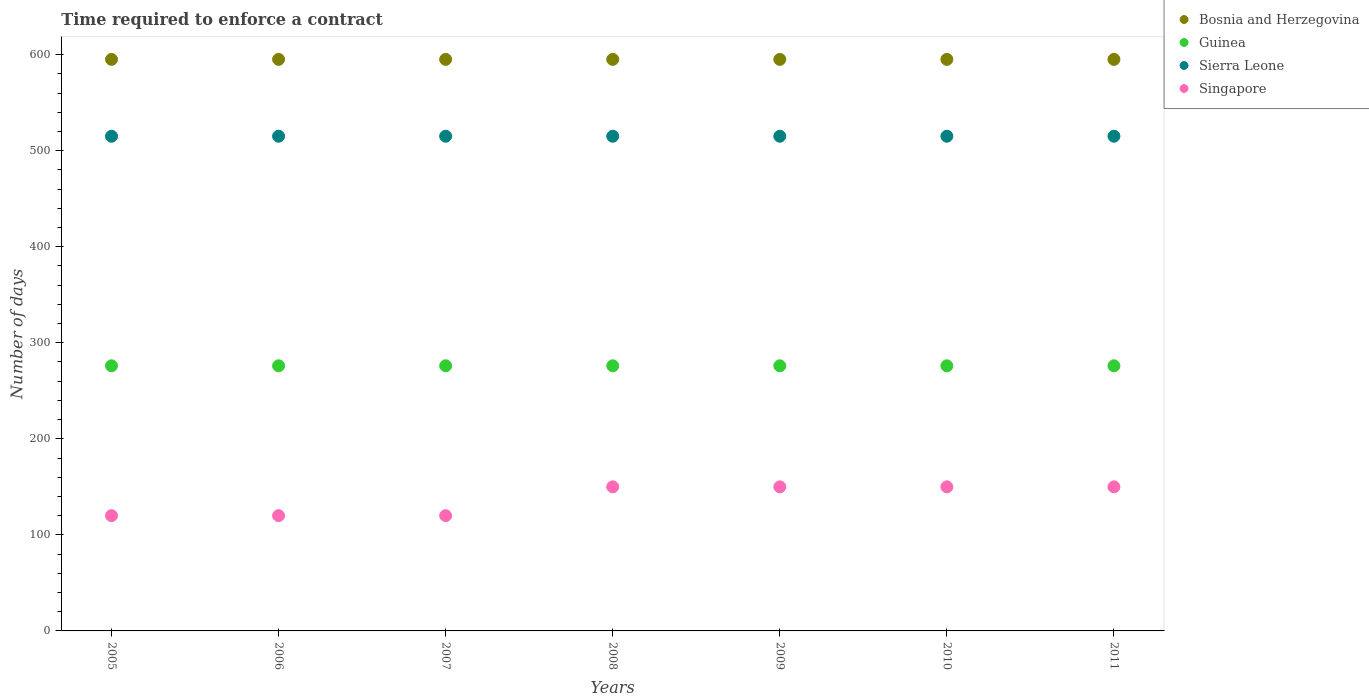How many different coloured dotlines are there?
Your response must be concise. 4. What is the number of days required to enforce a contract in Guinea in 2008?
Offer a terse response. 276. Across all years, what is the maximum number of days required to enforce a contract in Guinea?
Your response must be concise. 276. Across all years, what is the minimum number of days required to enforce a contract in Guinea?
Make the answer very short. 276. In which year was the number of days required to enforce a contract in Guinea maximum?
Give a very brief answer. 2005. In which year was the number of days required to enforce a contract in Bosnia and Herzegovina minimum?
Provide a short and direct response. 2005. What is the total number of days required to enforce a contract in Guinea in the graph?
Your response must be concise. 1932. What is the difference between the number of days required to enforce a contract in Guinea in 2011 and the number of days required to enforce a contract in Singapore in 2010?
Your answer should be compact. 126. What is the average number of days required to enforce a contract in Guinea per year?
Give a very brief answer. 276. In the year 2006, what is the difference between the number of days required to enforce a contract in Sierra Leone and number of days required to enforce a contract in Bosnia and Herzegovina?
Provide a short and direct response. -80. In how many years, is the number of days required to enforce a contract in Singapore greater than 580 days?
Offer a very short reply. 0. Is the number of days required to enforce a contract in Bosnia and Herzegovina in 2009 less than that in 2010?
Your answer should be compact. No. Is the difference between the number of days required to enforce a contract in Sierra Leone in 2007 and 2010 greater than the difference between the number of days required to enforce a contract in Bosnia and Herzegovina in 2007 and 2010?
Provide a succinct answer. No. What is the difference between the highest and the lowest number of days required to enforce a contract in Singapore?
Make the answer very short. 30. Is the number of days required to enforce a contract in Bosnia and Herzegovina strictly greater than the number of days required to enforce a contract in Sierra Leone over the years?
Provide a succinct answer. Yes. Is the number of days required to enforce a contract in Bosnia and Herzegovina strictly less than the number of days required to enforce a contract in Guinea over the years?
Your answer should be compact. No. How many years are there in the graph?
Offer a very short reply. 7. What is the difference between two consecutive major ticks on the Y-axis?
Provide a short and direct response. 100. Are the values on the major ticks of Y-axis written in scientific E-notation?
Give a very brief answer. No. Does the graph contain any zero values?
Your answer should be compact. No. How are the legend labels stacked?
Ensure brevity in your answer.  Vertical. What is the title of the graph?
Make the answer very short. Time required to enforce a contract. What is the label or title of the X-axis?
Make the answer very short. Years. What is the label or title of the Y-axis?
Offer a very short reply. Number of days. What is the Number of days in Bosnia and Herzegovina in 2005?
Give a very brief answer. 595. What is the Number of days in Guinea in 2005?
Your response must be concise. 276. What is the Number of days of Sierra Leone in 2005?
Offer a terse response. 515. What is the Number of days of Singapore in 2005?
Provide a short and direct response. 120. What is the Number of days of Bosnia and Herzegovina in 2006?
Ensure brevity in your answer.  595. What is the Number of days of Guinea in 2006?
Provide a succinct answer. 276. What is the Number of days of Sierra Leone in 2006?
Your answer should be compact. 515. What is the Number of days in Singapore in 2006?
Your response must be concise. 120. What is the Number of days of Bosnia and Herzegovina in 2007?
Offer a very short reply. 595. What is the Number of days of Guinea in 2007?
Keep it short and to the point. 276. What is the Number of days in Sierra Leone in 2007?
Keep it short and to the point. 515. What is the Number of days in Singapore in 2007?
Your response must be concise. 120. What is the Number of days of Bosnia and Herzegovina in 2008?
Ensure brevity in your answer.  595. What is the Number of days in Guinea in 2008?
Your answer should be compact. 276. What is the Number of days of Sierra Leone in 2008?
Offer a very short reply. 515. What is the Number of days in Singapore in 2008?
Your response must be concise. 150. What is the Number of days in Bosnia and Herzegovina in 2009?
Your response must be concise. 595. What is the Number of days in Guinea in 2009?
Provide a succinct answer. 276. What is the Number of days of Sierra Leone in 2009?
Offer a very short reply. 515. What is the Number of days of Singapore in 2009?
Keep it short and to the point. 150. What is the Number of days in Bosnia and Herzegovina in 2010?
Ensure brevity in your answer.  595. What is the Number of days of Guinea in 2010?
Make the answer very short. 276. What is the Number of days in Sierra Leone in 2010?
Your response must be concise. 515. What is the Number of days in Singapore in 2010?
Ensure brevity in your answer.  150. What is the Number of days of Bosnia and Herzegovina in 2011?
Offer a very short reply. 595. What is the Number of days in Guinea in 2011?
Provide a succinct answer. 276. What is the Number of days of Sierra Leone in 2011?
Keep it short and to the point. 515. What is the Number of days in Singapore in 2011?
Offer a terse response. 150. Across all years, what is the maximum Number of days in Bosnia and Herzegovina?
Keep it short and to the point. 595. Across all years, what is the maximum Number of days in Guinea?
Your response must be concise. 276. Across all years, what is the maximum Number of days of Sierra Leone?
Your answer should be very brief. 515. Across all years, what is the maximum Number of days of Singapore?
Keep it short and to the point. 150. Across all years, what is the minimum Number of days of Bosnia and Herzegovina?
Provide a short and direct response. 595. Across all years, what is the minimum Number of days in Guinea?
Your answer should be compact. 276. Across all years, what is the minimum Number of days of Sierra Leone?
Your response must be concise. 515. Across all years, what is the minimum Number of days in Singapore?
Offer a terse response. 120. What is the total Number of days of Bosnia and Herzegovina in the graph?
Provide a short and direct response. 4165. What is the total Number of days of Guinea in the graph?
Keep it short and to the point. 1932. What is the total Number of days of Sierra Leone in the graph?
Provide a short and direct response. 3605. What is the total Number of days of Singapore in the graph?
Make the answer very short. 960. What is the difference between the Number of days in Bosnia and Herzegovina in 2005 and that in 2006?
Provide a short and direct response. 0. What is the difference between the Number of days of Sierra Leone in 2005 and that in 2006?
Keep it short and to the point. 0. What is the difference between the Number of days in Singapore in 2005 and that in 2006?
Your response must be concise. 0. What is the difference between the Number of days in Guinea in 2005 and that in 2007?
Make the answer very short. 0. What is the difference between the Number of days in Sierra Leone in 2005 and that in 2007?
Make the answer very short. 0. What is the difference between the Number of days in Singapore in 2005 and that in 2007?
Your answer should be compact. 0. What is the difference between the Number of days of Singapore in 2005 and that in 2008?
Give a very brief answer. -30. What is the difference between the Number of days of Bosnia and Herzegovina in 2005 and that in 2009?
Keep it short and to the point. 0. What is the difference between the Number of days in Sierra Leone in 2005 and that in 2009?
Keep it short and to the point. 0. What is the difference between the Number of days in Singapore in 2005 and that in 2009?
Make the answer very short. -30. What is the difference between the Number of days in Sierra Leone in 2005 and that in 2010?
Your answer should be compact. 0. What is the difference between the Number of days in Singapore in 2005 and that in 2011?
Keep it short and to the point. -30. What is the difference between the Number of days of Bosnia and Herzegovina in 2006 and that in 2007?
Keep it short and to the point. 0. What is the difference between the Number of days of Sierra Leone in 2006 and that in 2007?
Ensure brevity in your answer.  0. What is the difference between the Number of days of Singapore in 2006 and that in 2007?
Offer a terse response. 0. What is the difference between the Number of days in Bosnia and Herzegovina in 2006 and that in 2008?
Ensure brevity in your answer.  0. What is the difference between the Number of days in Singapore in 2006 and that in 2008?
Your answer should be compact. -30. What is the difference between the Number of days in Guinea in 2006 and that in 2010?
Ensure brevity in your answer.  0. What is the difference between the Number of days in Singapore in 2006 and that in 2010?
Make the answer very short. -30. What is the difference between the Number of days in Bosnia and Herzegovina in 2006 and that in 2011?
Give a very brief answer. 0. What is the difference between the Number of days in Guinea in 2006 and that in 2011?
Offer a very short reply. 0. What is the difference between the Number of days in Sierra Leone in 2006 and that in 2011?
Ensure brevity in your answer.  0. What is the difference between the Number of days of Singapore in 2006 and that in 2011?
Your answer should be compact. -30. What is the difference between the Number of days in Guinea in 2007 and that in 2009?
Offer a very short reply. 0. What is the difference between the Number of days in Guinea in 2007 and that in 2010?
Ensure brevity in your answer.  0. What is the difference between the Number of days in Sierra Leone in 2007 and that in 2010?
Give a very brief answer. 0. What is the difference between the Number of days of Singapore in 2007 and that in 2010?
Give a very brief answer. -30. What is the difference between the Number of days of Guinea in 2007 and that in 2011?
Provide a short and direct response. 0. What is the difference between the Number of days in Singapore in 2007 and that in 2011?
Your answer should be very brief. -30. What is the difference between the Number of days of Guinea in 2008 and that in 2009?
Your response must be concise. 0. What is the difference between the Number of days of Singapore in 2008 and that in 2009?
Provide a short and direct response. 0. What is the difference between the Number of days in Bosnia and Herzegovina in 2008 and that in 2010?
Keep it short and to the point. 0. What is the difference between the Number of days of Guinea in 2008 and that in 2010?
Keep it short and to the point. 0. What is the difference between the Number of days in Sierra Leone in 2008 and that in 2010?
Your answer should be very brief. 0. What is the difference between the Number of days of Singapore in 2008 and that in 2010?
Keep it short and to the point. 0. What is the difference between the Number of days in Guinea in 2008 and that in 2011?
Your answer should be compact. 0. What is the difference between the Number of days in Singapore in 2008 and that in 2011?
Your answer should be very brief. 0. What is the difference between the Number of days in Guinea in 2009 and that in 2010?
Your response must be concise. 0. What is the difference between the Number of days of Sierra Leone in 2009 and that in 2010?
Keep it short and to the point. 0. What is the difference between the Number of days of Sierra Leone in 2009 and that in 2011?
Your answer should be compact. 0. What is the difference between the Number of days of Bosnia and Herzegovina in 2010 and that in 2011?
Your response must be concise. 0. What is the difference between the Number of days in Guinea in 2010 and that in 2011?
Your answer should be compact. 0. What is the difference between the Number of days in Singapore in 2010 and that in 2011?
Your answer should be very brief. 0. What is the difference between the Number of days in Bosnia and Herzegovina in 2005 and the Number of days in Guinea in 2006?
Your response must be concise. 319. What is the difference between the Number of days in Bosnia and Herzegovina in 2005 and the Number of days in Singapore in 2006?
Keep it short and to the point. 475. What is the difference between the Number of days of Guinea in 2005 and the Number of days of Sierra Leone in 2006?
Your answer should be compact. -239. What is the difference between the Number of days in Guinea in 2005 and the Number of days in Singapore in 2006?
Give a very brief answer. 156. What is the difference between the Number of days of Sierra Leone in 2005 and the Number of days of Singapore in 2006?
Your answer should be compact. 395. What is the difference between the Number of days of Bosnia and Herzegovina in 2005 and the Number of days of Guinea in 2007?
Offer a terse response. 319. What is the difference between the Number of days in Bosnia and Herzegovina in 2005 and the Number of days in Singapore in 2007?
Your answer should be compact. 475. What is the difference between the Number of days in Guinea in 2005 and the Number of days in Sierra Leone in 2007?
Your answer should be compact. -239. What is the difference between the Number of days of Guinea in 2005 and the Number of days of Singapore in 2007?
Your response must be concise. 156. What is the difference between the Number of days in Sierra Leone in 2005 and the Number of days in Singapore in 2007?
Make the answer very short. 395. What is the difference between the Number of days in Bosnia and Herzegovina in 2005 and the Number of days in Guinea in 2008?
Ensure brevity in your answer.  319. What is the difference between the Number of days of Bosnia and Herzegovina in 2005 and the Number of days of Singapore in 2008?
Your response must be concise. 445. What is the difference between the Number of days in Guinea in 2005 and the Number of days in Sierra Leone in 2008?
Offer a terse response. -239. What is the difference between the Number of days in Guinea in 2005 and the Number of days in Singapore in 2008?
Provide a short and direct response. 126. What is the difference between the Number of days of Sierra Leone in 2005 and the Number of days of Singapore in 2008?
Provide a short and direct response. 365. What is the difference between the Number of days in Bosnia and Herzegovina in 2005 and the Number of days in Guinea in 2009?
Provide a succinct answer. 319. What is the difference between the Number of days in Bosnia and Herzegovina in 2005 and the Number of days in Singapore in 2009?
Offer a very short reply. 445. What is the difference between the Number of days of Guinea in 2005 and the Number of days of Sierra Leone in 2009?
Keep it short and to the point. -239. What is the difference between the Number of days of Guinea in 2005 and the Number of days of Singapore in 2009?
Ensure brevity in your answer.  126. What is the difference between the Number of days in Sierra Leone in 2005 and the Number of days in Singapore in 2009?
Give a very brief answer. 365. What is the difference between the Number of days in Bosnia and Herzegovina in 2005 and the Number of days in Guinea in 2010?
Make the answer very short. 319. What is the difference between the Number of days of Bosnia and Herzegovina in 2005 and the Number of days of Sierra Leone in 2010?
Provide a short and direct response. 80. What is the difference between the Number of days of Bosnia and Herzegovina in 2005 and the Number of days of Singapore in 2010?
Ensure brevity in your answer.  445. What is the difference between the Number of days in Guinea in 2005 and the Number of days in Sierra Leone in 2010?
Your answer should be compact. -239. What is the difference between the Number of days of Guinea in 2005 and the Number of days of Singapore in 2010?
Keep it short and to the point. 126. What is the difference between the Number of days in Sierra Leone in 2005 and the Number of days in Singapore in 2010?
Your response must be concise. 365. What is the difference between the Number of days in Bosnia and Herzegovina in 2005 and the Number of days in Guinea in 2011?
Your response must be concise. 319. What is the difference between the Number of days of Bosnia and Herzegovina in 2005 and the Number of days of Sierra Leone in 2011?
Keep it short and to the point. 80. What is the difference between the Number of days in Bosnia and Herzegovina in 2005 and the Number of days in Singapore in 2011?
Give a very brief answer. 445. What is the difference between the Number of days in Guinea in 2005 and the Number of days in Sierra Leone in 2011?
Offer a very short reply. -239. What is the difference between the Number of days in Guinea in 2005 and the Number of days in Singapore in 2011?
Offer a very short reply. 126. What is the difference between the Number of days of Sierra Leone in 2005 and the Number of days of Singapore in 2011?
Provide a succinct answer. 365. What is the difference between the Number of days in Bosnia and Herzegovina in 2006 and the Number of days in Guinea in 2007?
Your response must be concise. 319. What is the difference between the Number of days of Bosnia and Herzegovina in 2006 and the Number of days of Singapore in 2007?
Provide a short and direct response. 475. What is the difference between the Number of days in Guinea in 2006 and the Number of days in Sierra Leone in 2007?
Keep it short and to the point. -239. What is the difference between the Number of days in Guinea in 2006 and the Number of days in Singapore in 2007?
Offer a terse response. 156. What is the difference between the Number of days in Sierra Leone in 2006 and the Number of days in Singapore in 2007?
Your answer should be very brief. 395. What is the difference between the Number of days in Bosnia and Herzegovina in 2006 and the Number of days in Guinea in 2008?
Offer a very short reply. 319. What is the difference between the Number of days of Bosnia and Herzegovina in 2006 and the Number of days of Singapore in 2008?
Offer a very short reply. 445. What is the difference between the Number of days of Guinea in 2006 and the Number of days of Sierra Leone in 2008?
Provide a short and direct response. -239. What is the difference between the Number of days in Guinea in 2006 and the Number of days in Singapore in 2008?
Your answer should be compact. 126. What is the difference between the Number of days of Sierra Leone in 2006 and the Number of days of Singapore in 2008?
Give a very brief answer. 365. What is the difference between the Number of days of Bosnia and Herzegovina in 2006 and the Number of days of Guinea in 2009?
Give a very brief answer. 319. What is the difference between the Number of days of Bosnia and Herzegovina in 2006 and the Number of days of Sierra Leone in 2009?
Ensure brevity in your answer.  80. What is the difference between the Number of days of Bosnia and Herzegovina in 2006 and the Number of days of Singapore in 2009?
Your answer should be very brief. 445. What is the difference between the Number of days of Guinea in 2006 and the Number of days of Sierra Leone in 2009?
Make the answer very short. -239. What is the difference between the Number of days in Guinea in 2006 and the Number of days in Singapore in 2009?
Your answer should be compact. 126. What is the difference between the Number of days in Sierra Leone in 2006 and the Number of days in Singapore in 2009?
Your answer should be compact. 365. What is the difference between the Number of days of Bosnia and Herzegovina in 2006 and the Number of days of Guinea in 2010?
Make the answer very short. 319. What is the difference between the Number of days in Bosnia and Herzegovina in 2006 and the Number of days in Singapore in 2010?
Provide a succinct answer. 445. What is the difference between the Number of days of Guinea in 2006 and the Number of days of Sierra Leone in 2010?
Offer a very short reply. -239. What is the difference between the Number of days of Guinea in 2006 and the Number of days of Singapore in 2010?
Give a very brief answer. 126. What is the difference between the Number of days of Sierra Leone in 2006 and the Number of days of Singapore in 2010?
Your answer should be very brief. 365. What is the difference between the Number of days in Bosnia and Herzegovina in 2006 and the Number of days in Guinea in 2011?
Make the answer very short. 319. What is the difference between the Number of days of Bosnia and Herzegovina in 2006 and the Number of days of Sierra Leone in 2011?
Provide a succinct answer. 80. What is the difference between the Number of days in Bosnia and Herzegovina in 2006 and the Number of days in Singapore in 2011?
Ensure brevity in your answer.  445. What is the difference between the Number of days of Guinea in 2006 and the Number of days of Sierra Leone in 2011?
Ensure brevity in your answer.  -239. What is the difference between the Number of days in Guinea in 2006 and the Number of days in Singapore in 2011?
Ensure brevity in your answer.  126. What is the difference between the Number of days in Sierra Leone in 2006 and the Number of days in Singapore in 2011?
Provide a succinct answer. 365. What is the difference between the Number of days in Bosnia and Herzegovina in 2007 and the Number of days in Guinea in 2008?
Give a very brief answer. 319. What is the difference between the Number of days of Bosnia and Herzegovina in 2007 and the Number of days of Singapore in 2008?
Ensure brevity in your answer.  445. What is the difference between the Number of days of Guinea in 2007 and the Number of days of Sierra Leone in 2008?
Offer a terse response. -239. What is the difference between the Number of days of Guinea in 2007 and the Number of days of Singapore in 2008?
Ensure brevity in your answer.  126. What is the difference between the Number of days in Sierra Leone in 2007 and the Number of days in Singapore in 2008?
Ensure brevity in your answer.  365. What is the difference between the Number of days of Bosnia and Herzegovina in 2007 and the Number of days of Guinea in 2009?
Keep it short and to the point. 319. What is the difference between the Number of days in Bosnia and Herzegovina in 2007 and the Number of days in Singapore in 2009?
Ensure brevity in your answer.  445. What is the difference between the Number of days of Guinea in 2007 and the Number of days of Sierra Leone in 2009?
Give a very brief answer. -239. What is the difference between the Number of days of Guinea in 2007 and the Number of days of Singapore in 2009?
Provide a short and direct response. 126. What is the difference between the Number of days of Sierra Leone in 2007 and the Number of days of Singapore in 2009?
Give a very brief answer. 365. What is the difference between the Number of days in Bosnia and Herzegovina in 2007 and the Number of days in Guinea in 2010?
Your answer should be compact. 319. What is the difference between the Number of days of Bosnia and Herzegovina in 2007 and the Number of days of Singapore in 2010?
Ensure brevity in your answer.  445. What is the difference between the Number of days in Guinea in 2007 and the Number of days in Sierra Leone in 2010?
Provide a short and direct response. -239. What is the difference between the Number of days in Guinea in 2007 and the Number of days in Singapore in 2010?
Provide a succinct answer. 126. What is the difference between the Number of days in Sierra Leone in 2007 and the Number of days in Singapore in 2010?
Make the answer very short. 365. What is the difference between the Number of days of Bosnia and Herzegovina in 2007 and the Number of days of Guinea in 2011?
Offer a very short reply. 319. What is the difference between the Number of days in Bosnia and Herzegovina in 2007 and the Number of days in Sierra Leone in 2011?
Provide a short and direct response. 80. What is the difference between the Number of days of Bosnia and Herzegovina in 2007 and the Number of days of Singapore in 2011?
Your response must be concise. 445. What is the difference between the Number of days of Guinea in 2007 and the Number of days of Sierra Leone in 2011?
Provide a short and direct response. -239. What is the difference between the Number of days in Guinea in 2007 and the Number of days in Singapore in 2011?
Make the answer very short. 126. What is the difference between the Number of days in Sierra Leone in 2007 and the Number of days in Singapore in 2011?
Offer a terse response. 365. What is the difference between the Number of days in Bosnia and Herzegovina in 2008 and the Number of days in Guinea in 2009?
Provide a succinct answer. 319. What is the difference between the Number of days in Bosnia and Herzegovina in 2008 and the Number of days in Singapore in 2009?
Offer a very short reply. 445. What is the difference between the Number of days of Guinea in 2008 and the Number of days of Sierra Leone in 2009?
Offer a terse response. -239. What is the difference between the Number of days of Guinea in 2008 and the Number of days of Singapore in 2009?
Your response must be concise. 126. What is the difference between the Number of days of Sierra Leone in 2008 and the Number of days of Singapore in 2009?
Provide a short and direct response. 365. What is the difference between the Number of days in Bosnia and Herzegovina in 2008 and the Number of days in Guinea in 2010?
Your response must be concise. 319. What is the difference between the Number of days of Bosnia and Herzegovina in 2008 and the Number of days of Sierra Leone in 2010?
Provide a succinct answer. 80. What is the difference between the Number of days in Bosnia and Herzegovina in 2008 and the Number of days in Singapore in 2010?
Offer a very short reply. 445. What is the difference between the Number of days of Guinea in 2008 and the Number of days of Sierra Leone in 2010?
Offer a very short reply. -239. What is the difference between the Number of days of Guinea in 2008 and the Number of days of Singapore in 2010?
Offer a terse response. 126. What is the difference between the Number of days of Sierra Leone in 2008 and the Number of days of Singapore in 2010?
Your answer should be compact. 365. What is the difference between the Number of days in Bosnia and Herzegovina in 2008 and the Number of days in Guinea in 2011?
Make the answer very short. 319. What is the difference between the Number of days in Bosnia and Herzegovina in 2008 and the Number of days in Sierra Leone in 2011?
Provide a short and direct response. 80. What is the difference between the Number of days in Bosnia and Herzegovina in 2008 and the Number of days in Singapore in 2011?
Make the answer very short. 445. What is the difference between the Number of days in Guinea in 2008 and the Number of days in Sierra Leone in 2011?
Your answer should be very brief. -239. What is the difference between the Number of days in Guinea in 2008 and the Number of days in Singapore in 2011?
Offer a very short reply. 126. What is the difference between the Number of days in Sierra Leone in 2008 and the Number of days in Singapore in 2011?
Keep it short and to the point. 365. What is the difference between the Number of days of Bosnia and Herzegovina in 2009 and the Number of days of Guinea in 2010?
Make the answer very short. 319. What is the difference between the Number of days of Bosnia and Herzegovina in 2009 and the Number of days of Singapore in 2010?
Make the answer very short. 445. What is the difference between the Number of days of Guinea in 2009 and the Number of days of Sierra Leone in 2010?
Ensure brevity in your answer.  -239. What is the difference between the Number of days in Guinea in 2009 and the Number of days in Singapore in 2010?
Your response must be concise. 126. What is the difference between the Number of days in Sierra Leone in 2009 and the Number of days in Singapore in 2010?
Your answer should be compact. 365. What is the difference between the Number of days in Bosnia and Herzegovina in 2009 and the Number of days in Guinea in 2011?
Make the answer very short. 319. What is the difference between the Number of days of Bosnia and Herzegovina in 2009 and the Number of days of Singapore in 2011?
Provide a succinct answer. 445. What is the difference between the Number of days in Guinea in 2009 and the Number of days in Sierra Leone in 2011?
Offer a very short reply. -239. What is the difference between the Number of days of Guinea in 2009 and the Number of days of Singapore in 2011?
Offer a terse response. 126. What is the difference between the Number of days of Sierra Leone in 2009 and the Number of days of Singapore in 2011?
Offer a terse response. 365. What is the difference between the Number of days in Bosnia and Herzegovina in 2010 and the Number of days in Guinea in 2011?
Ensure brevity in your answer.  319. What is the difference between the Number of days of Bosnia and Herzegovina in 2010 and the Number of days of Singapore in 2011?
Your answer should be very brief. 445. What is the difference between the Number of days in Guinea in 2010 and the Number of days in Sierra Leone in 2011?
Offer a terse response. -239. What is the difference between the Number of days of Guinea in 2010 and the Number of days of Singapore in 2011?
Provide a short and direct response. 126. What is the difference between the Number of days of Sierra Leone in 2010 and the Number of days of Singapore in 2011?
Provide a short and direct response. 365. What is the average Number of days of Bosnia and Herzegovina per year?
Your response must be concise. 595. What is the average Number of days of Guinea per year?
Offer a very short reply. 276. What is the average Number of days in Sierra Leone per year?
Your response must be concise. 515. What is the average Number of days in Singapore per year?
Make the answer very short. 137.14. In the year 2005, what is the difference between the Number of days in Bosnia and Herzegovina and Number of days in Guinea?
Your answer should be compact. 319. In the year 2005, what is the difference between the Number of days of Bosnia and Herzegovina and Number of days of Sierra Leone?
Provide a succinct answer. 80. In the year 2005, what is the difference between the Number of days in Bosnia and Herzegovina and Number of days in Singapore?
Offer a terse response. 475. In the year 2005, what is the difference between the Number of days of Guinea and Number of days of Sierra Leone?
Keep it short and to the point. -239. In the year 2005, what is the difference between the Number of days of Guinea and Number of days of Singapore?
Offer a terse response. 156. In the year 2005, what is the difference between the Number of days in Sierra Leone and Number of days in Singapore?
Your response must be concise. 395. In the year 2006, what is the difference between the Number of days of Bosnia and Herzegovina and Number of days of Guinea?
Make the answer very short. 319. In the year 2006, what is the difference between the Number of days of Bosnia and Herzegovina and Number of days of Sierra Leone?
Ensure brevity in your answer.  80. In the year 2006, what is the difference between the Number of days of Bosnia and Herzegovina and Number of days of Singapore?
Your answer should be compact. 475. In the year 2006, what is the difference between the Number of days of Guinea and Number of days of Sierra Leone?
Your answer should be very brief. -239. In the year 2006, what is the difference between the Number of days of Guinea and Number of days of Singapore?
Offer a terse response. 156. In the year 2006, what is the difference between the Number of days of Sierra Leone and Number of days of Singapore?
Your response must be concise. 395. In the year 2007, what is the difference between the Number of days of Bosnia and Herzegovina and Number of days of Guinea?
Your answer should be compact. 319. In the year 2007, what is the difference between the Number of days of Bosnia and Herzegovina and Number of days of Singapore?
Keep it short and to the point. 475. In the year 2007, what is the difference between the Number of days of Guinea and Number of days of Sierra Leone?
Give a very brief answer. -239. In the year 2007, what is the difference between the Number of days in Guinea and Number of days in Singapore?
Offer a terse response. 156. In the year 2007, what is the difference between the Number of days in Sierra Leone and Number of days in Singapore?
Offer a terse response. 395. In the year 2008, what is the difference between the Number of days of Bosnia and Herzegovina and Number of days of Guinea?
Your response must be concise. 319. In the year 2008, what is the difference between the Number of days of Bosnia and Herzegovina and Number of days of Singapore?
Offer a terse response. 445. In the year 2008, what is the difference between the Number of days in Guinea and Number of days in Sierra Leone?
Your answer should be very brief. -239. In the year 2008, what is the difference between the Number of days in Guinea and Number of days in Singapore?
Your response must be concise. 126. In the year 2008, what is the difference between the Number of days of Sierra Leone and Number of days of Singapore?
Your response must be concise. 365. In the year 2009, what is the difference between the Number of days of Bosnia and Herzegovina and Number of days of Guinea?
Provide a succinct answer. 319. In the year 2009, what is the difference between the Number of days of Bosnia and Herzegovina and Number of days of Singapore?
Offer a terse response. 445. In the year 2009, what is the difference between the Number of days of Guinea and Number of days of Sierra Leone?
Your answer should be very brief. -239. In the year 2009, what is the difference between the Number of days in Guinea and Number of days in Singapore?
Offer a terse response. 126. In the year 2009, what is the difference between the Number of days of Sierra Leone and Number of days of Singapore?
Give a very brief answer. 365. In the year 2010, what is the difference between the Number of days in Bosnia and Herzegovina and Number of days in Guinea?
Your response must be concise. 319. In the year 2010, what is the difference between the Number of days of Bosnia and Herzegovina and Number of days of Singapore?
Your answer should be very brief. 445. In the year 2010, what is the difference between the Number of days of Guinea and Number of days of Sierra Leone?
Keep it short and to the point. -239. In the year 2010, what is the difference between the Number of days of Guinea and Number of days of Singapore?
Give a very brief answer. 126. In the year 2010, what is the difference between the Number of days of Sierra Leone and Number of days of Singapore?
Offer a terse response. 365. In the year 2011, what is the difference between the Number of days in Bosnia and Herzegovina and Number of days in Guinea?
Offer a terse response. 319. In the year 2011, what is the difference between the Number of days in Bosnia and Herzegovina and Number of days in Sierra Leone?
Your response must be concise. 80. In the year 2011, what is the difference between the Number of days in Bosnia and Herzegovina and Number of days in Singapore?
Offer a very short reply. 445. In the year 2011, what is the difference between the Number of days of Guinea and Number of days of Sierra Leone?
Provide a succinct answer. -239. In the year 2011, what is the difference between the Number of days in Guinea and Number of days in Singapore?
Your answer should be compact. 126. In the year 2011, what is the difference between the Number of days of Sierra Leone and Number of days of Singapore?
Your response must be concise. 365. What is the ratio of the Number of days in Guinea in 2005 to that in 2006?
Your answer should be compact. 1. What is the ratio of the Number of days in Sierra Leone in 2005 to that in 2007?
Provide a succinct answer. 1. What is the ratio of the Number of days in Singapore in 2005 to that in 2007?
Your response must be concise. 1. What is the ratio of the Number of days of Sierra Leone in 2005 to that in 2008?
Give a very brief answer. 1. What is the ratio of the Number of days in Guinea in 2005 to that in 2009?
Provide a short and direct response. 1. What is the ratio of the Number of days in Singapore in 2005 to that in 2009?
Your answer should be very brief. 0.8. What is the ratio of the Number of days in Bosnia and Herzegovina in 2005 to that in 2011?
Provide a succinct answer. 1. What is the ratio of the Number of days of Singapore in 2005 to that in 2011?
Your response must be concise. 0.8. What is the ratio of the Number of days in Guinea in 2006 to that in 2007?
Your response must be concise. 1. What is the ratio of the Number of days of Sierra Leone in 2006 to that in 2007?
Make the answer very short. 1. What is the ratio of the Number of days of Singapore in 2006 to that in 2007?
Make the answer very short. 1. What is the ratio of the Number of days of Bosnia and Herzegovina in 2006 to that in 2008?
Your response must be concise. 1. What is the ratio of the Number of days of Guinea in 2006 to that in 2008?
Give a very brief answer. 1. What is the ratio of the Number of days in Sierra Leone in 2006 to that in 2008?
Offer a very short reply. 1. What is the ratio of the Number of days in Singapore in 2006 to that in 2008?
Offer a very short reply. 0.8. What is the ratio of the Number of days in Bosnia and Herzegovina in 2006 to that in 2009?
Give a very brief answer. 1. What is the ratio of the Number of days in Singapore in 2006 to that in 2009?
Keep it short and to the point. 0.8. What is the ratio of the Number of days of Bosnia and Herzegovina in 2006 to that in 2011?
Keep it short and to the point. 1. What is the ratio of the Number of days in Sierra Leone in 2006 to that in 2011?
Your response must be concise. 1. What is the ratio of the Number of days in Singapore in 2006 to that in 2011?
Ensure brevity in your answer.  0.8. What is the ratio of the Number of days in Bosnia and Herzegovina in 2007 to that in 2008?
Offer a very short reply. 1. What is the ratio of the Number of days of Sierra Leone in 2007 to that in 2008?
Provide a succinct answer. 1. What is the ratio of the Number of days in Bosnia and Herzegovina in 2007 to that in 2009?
Your answer should be very brief. 1. What is the ratio of the Number of days of Guinea in 2007 to that in 2009?
Make the answer very short. 1. What is the ratio of the Number of days in Sierra Leone in 2007 to that in 2010?
Keep it short and to the point. 1. What is the ratio of the Number of days of Singapore in 2007 to that in 2010?
Keep it short and to the point. 0.8. What is the ratio of the Number of days in Bosnia and Herzegovina in 2007 to that in 2011?
Provide a short and direct response. 1. What is the ratio of the Number of days in Guinea in 2007 to that in 2011?
Give a very brief answer. 1. What is the ratio of the Number of days of Bosnia and Herzegovina in 2008 to that in 2009?
Keep it short and to the point. 1. What is the ratio of the Number of days in Singapore in 2008 to that in 2009?
Ensure brevity in your answer.  1. What is the ratio of the Number of days in Sierra Leone in 2008 to that in 2010?
Your response must be concise. 1. What is the ratio of the Number of days of Bosnia and Herzegovina in 2008 to that in 2011?
Your answer should be compact. 1. What is the ratio of the Number of days of Sierra Leone in 2008 to that in 2011?
Your response must be concise. 1. What is the ratio of the Number of days in Singapore in 2008 to that in 2011?
Keep it short and to the point. 1. What is the ratio of the Number of days in Bosnia and Herzegovina in 2009 to that in 2010?
Your response must be concise. 1. What is the ratio of the Number of days in Bosnia and Herzegovina in 2009 to that in 2011?
Your response must be concise. 1. What is the ratio of the Number of days of Sierra Leone in 2010 to that in 2011?
Provide a short and direct response. 1. What is the difference between the highest and the second highest Number of days of Bosnia and Herzegovina?
Your answer should be very brief. 0. What is the difference between the highest and the second highest Number of days of Guinea?
Offer a very short reply. 0. What is the difference between the highest and the second highest Number of days of Singapore?
Ensure brevity in your answer.  0. What is the difference between the highest and the lowest Number of days of Bosnia and Herzegovina?
Offer a terse response. 0. What is the difference between the highest and the lowest Number of days of Guinea?
Ensure brevity in your answer.  0. What is the difference between the highest and the lowest Number of days in Sierra Leone?
Keep it short and to the point. 0. What is the difference between the highest and the lowest Number of days of Singapore?
Provide a short and direct response. 30. 